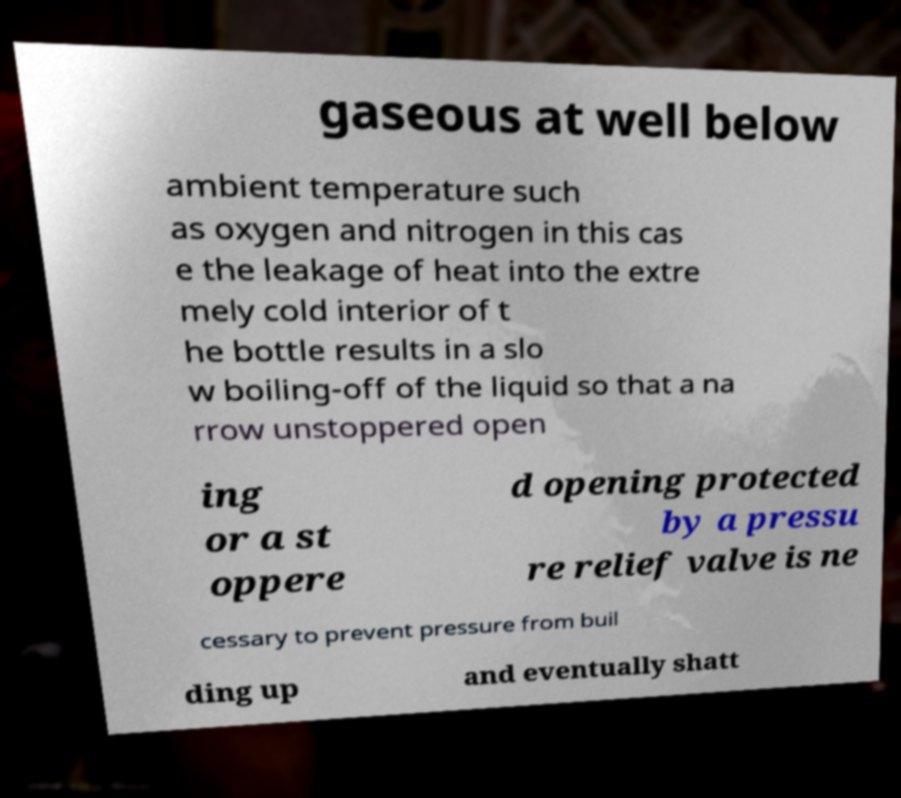I need the written content from this picture converted into text. Can you do that? gaseous at well below ambient temperature such as oxygen and nitrogen in this cas e the leakage of heat into the extre mely cold interior of t he bottle results in a slo w boiling-off of the liquid so that a na rrow unstoppered open ing or a st oppere d opening protected by a pressu re relief valve is ne cessary to prevent pressure from buil ding up and eventually shatt 